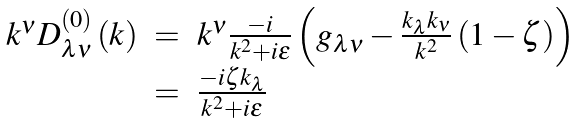<formula> <loc_0><loc_0><loc_500><loc_500>\begin{array} { r c l } k ^ { \nu } D _ { \lambda \nu } ^ { \left ( 0 \right ) } \left ( k \right ) & = & k ^ { \nu } \frac { - i } { k ^ { 2 } + i \epsilon } \left ( g _ { \lambda \nu } - \frac { k _ { \lambda } k _ { \nu } } { k ^ { 2 } } \left ( 1 - \zeta \right ) \right ) \\ & = & \frac { - i \zeta k _ { \lambda } } { k ^ { 2 } + i \epsilon } \end{array}</formula> 